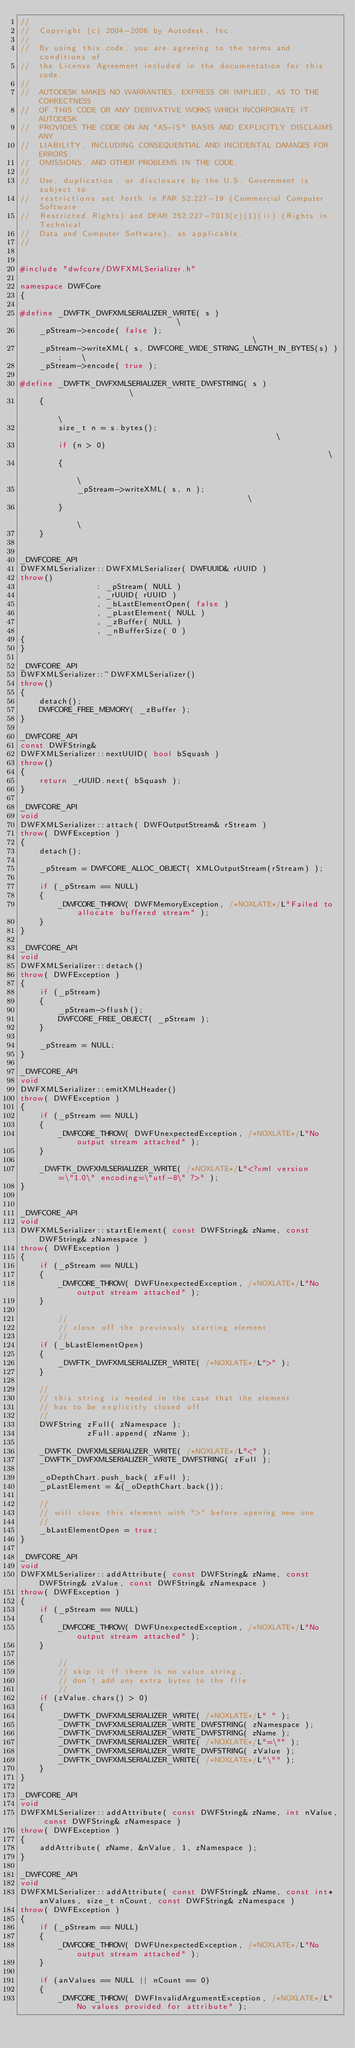Convert code to text. <code><loc_0><loc_0><loc_500><loc_500><_C++_>//
//  Copyright (c) 2004-2006 by Autodesk, Inc.
//
//  By using this code, you are agreeing to the terms and conditions of
//  the License Agreement included in the documentation for this code.
//
//  AUTODESK MAKES NO WARRANTIES, EXPRESS OR IMPLIED, AS TO THE CORRECTNESS
//  OF THIS CODE OR ANY DERIVATIVE WORKS WHICH INCORPORATE IT. AUTODESK
//  PROVIDES THE CODE ON AN "AS-IS" BASIS AND EXPLICITLY DISCLAIMS ANY
//  LIABILITY, INCLUDING CONSEQUENTIAL AND INCIDENTAL DAMAGES FOR ERRORS,
//  OMISSIONS, AND OTHER PROBLEMS IN THE CODE.
//
//  Use, duplication, or disclosure by the U.S. Government is subject to
//  restrictions set forth in FAR 52.227-19 (Commercial Computer Software
//  Restricted Rights) and DFAR 252.227-7013(c)(1)(ii) (Rights in Technical
//  Data and Computer Software), as applicable.
//


#include "dwfcore/DWFXMLSerializer.h"

namespace DWFCore
{

#define _DWFTK_DWFXMLSERIALIZER_WRITE( s )                              \
    _pStream->encode( false );                                          \
    _pStream->writeXML( s, DWFCORE_WIDE_STRING_LENGTH_IN_BYTES(s) );    \
    _pStream->encode( true );

#define _DWFTK_DWFXMLSERIALIZER_WRITE_DWFSTRING( s )                    \
    {                                                                   \
        size_t n = s.bytes();                                           \
        if (n > 0)                                                      \
        {                                                               \
            _pStream->writeXML( s, n );                                 \
        }                                                               \
    }


_DWFCORE_API
DWFXMLSerializer::DWFXMLSerializer( DWFUUID& rUUID )
throw()
                : _pStream( NULL )
                , _rUUID( rUUID )
                , _bLastElementOpen( false )
                , _pLastElement( NULL )
                , _zBuffer( NULL )
                , _nBufferSize( 0 )
{
}

_DWFCORE_API
DWFXMLSerializer::~DWFXMLSerializer()
throw()
{
    detach();
    DWFCORE_FREE_MEMORY( _zBuffer );
}

_DWFCORE_API
const DWFString&
DWFXMLSerializer::nextUUID( bool bSquash )
throw()
{
    return _rUUID.next( bSquash );
}

_DWFCORE_API
void
DWFXMLSerializer::attach( DWFOutputStream& rStream )
throw( DWFException )
{
    detach();

    _pStream = DWFCORE_ALLOC_OBJECT( XMLOutputStream(rStream) );

    if (_pStream == NULL)
    {
        _DWFCORE_THROW( DWFMemoryException, /*NOXLATE*/L"Failed to allocate buffered stream" );
    }
}

_DWFCORE_API
void
DWFXMLSerializer::detach()
throw( DWFException )
{
    if (_pStream)
    {
        _pStream->flush();
        DWFCORE_FREE_OBJECT( _pStream );
    }

    _pStream = NULL;
}

_DWFCORE_API
void
DWFXMLSerializer::emitXMLHeader()
throw( DWFException )
{
    if (_pStream == NULL)
    {
        _DWFCORE_THROW( DWFUnexpectedException, /*NOXLATE*/L"No output stream attached" );
    }

    _DWFTK_DWFXMLSERIALIZER_WRITE( /*NOXLATE*/L"<?xml version=\"1.0\" encoding=\"utf-8\" ?>" );
}


_DWFCORE_API
void
DWFXMLSerializer::startElement( const DWFString& zName, const DWFString& zNamespace )
throw( DWFException )
{
    if (_pStream == NULL)
    {
        _DWFCORE_THROW( DWFUnexpectedException, /*NOXLATE*/L"No output stream attached" );
    }

        //
        // close off the previously starting element
        //
    if (_bLastElementOpen)
    {
        _DWFTK_DWFXMLSERIALIZER_WRITE( /*NOXLATE*/L">" );
    }

    //
    // this string is needed in the case that the element
    // has to be explicitly closed off
    //
    DWFString zFull( zNamespace );
              zFull.append( zName );

    _DWFTK_DWFXMLSERIALIZER_WRITE( /*NOXLATE*/L"<" );
    _DWFTK_DWFXMLSERIALIZER_WRITE_DWFSTRING( zFull );

    _oDepthChart.push_back( zFull );
    _pLastElement = &(_oDepthChart.back());

    //
    // will close this element with ">" before opening new one
    //
    _bLastElementOpen = true;
}

_DWFCORE_API
void
DWFXMLSerializer::addAttribute( const DWFString& zName, const DWFString& zValue, const DWFString& zNamespace )
throw( DWFException )
{
    if (_pStream == NULL)
    {
        _DWFCORE_THROW( DWFUnexpectedException, /*NOXLATE*/L"No output stream attached" );
    }

        //
        // skip it if there is no value string,
        // don't add any extra bytes to the file
        //
    if (zValue.chars() > 0)
    {
        _DWFTK_DWFXMLSERIALIZER_WRITE( /*NOXLATE*/L" " );
        _DWFTK_DWFXMLSERIALIZER_WRITE_DWFSTRING( zNamespace );
        _DWFTK_DWFXMLSERIALIZER_WRITE_DWFSTRING( zName );
        _DWFTK_DWFXMLSERIALIZER_WRITE( /*NOXLATE*/L"=\"" );
        _DWFTK_DWFXMLSERIALIZER_WRITE_DWFSTRING( zValue );
        _DWFTK_DWFXMLSERIALIZER_WRITE( /*NOXLATE*/L"\"" );
    }
}

_DWFCORE_API
void
DWFXMLSerializer::addAttribute( const DWFString& zName, int nValue, const DWFString& zNamespace )
throw( DWFException )
{
    addAttribute( zName, &nValue, 1, zNamespace );
}

_DWFCORE_API
void
DWFXMLSerializer::addAttribute( const DWFString& zName, const int* anValues, size_t nCount, const DWFString& zNamespace )
throw( DWFException )
{
    if (_pStream == NULL)
    {
        _DWFCORE_THROW( DWFUnexpectedException, /*NOXLATE*/L"No output stream attached" );
    }

    if (anValues == NULL || nCount == 0)
    {
        _DWFCORE_THROW( DWFInvalidArgumentException, /*NOXLATE*/L"No values provided for attribute" );</code> 